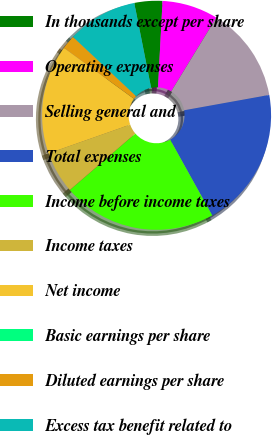<chart> <loc_0><loc_0><loc_500><loc_500><pie_chart><fcel>In thousands except per share<fcel>Operating expenses<fcel>Selling general and<fcel>Total expenses<fcel>Income before income taxes<fcel>Income taxes<fcel>Net income<fcel>Basic earnings per share<fcel>Diluted earnings per share<fcel>Excess tax benefit related to<nl><fcel>3.95%<fcel>7.91%<fcel>13.42%<fcel>19.77%<fcel>21.75%<fcel>5.93%<fcel>15.4%<fcel>0.0%<fcel>1.98%<fcel>9.89%<nl></chart> 